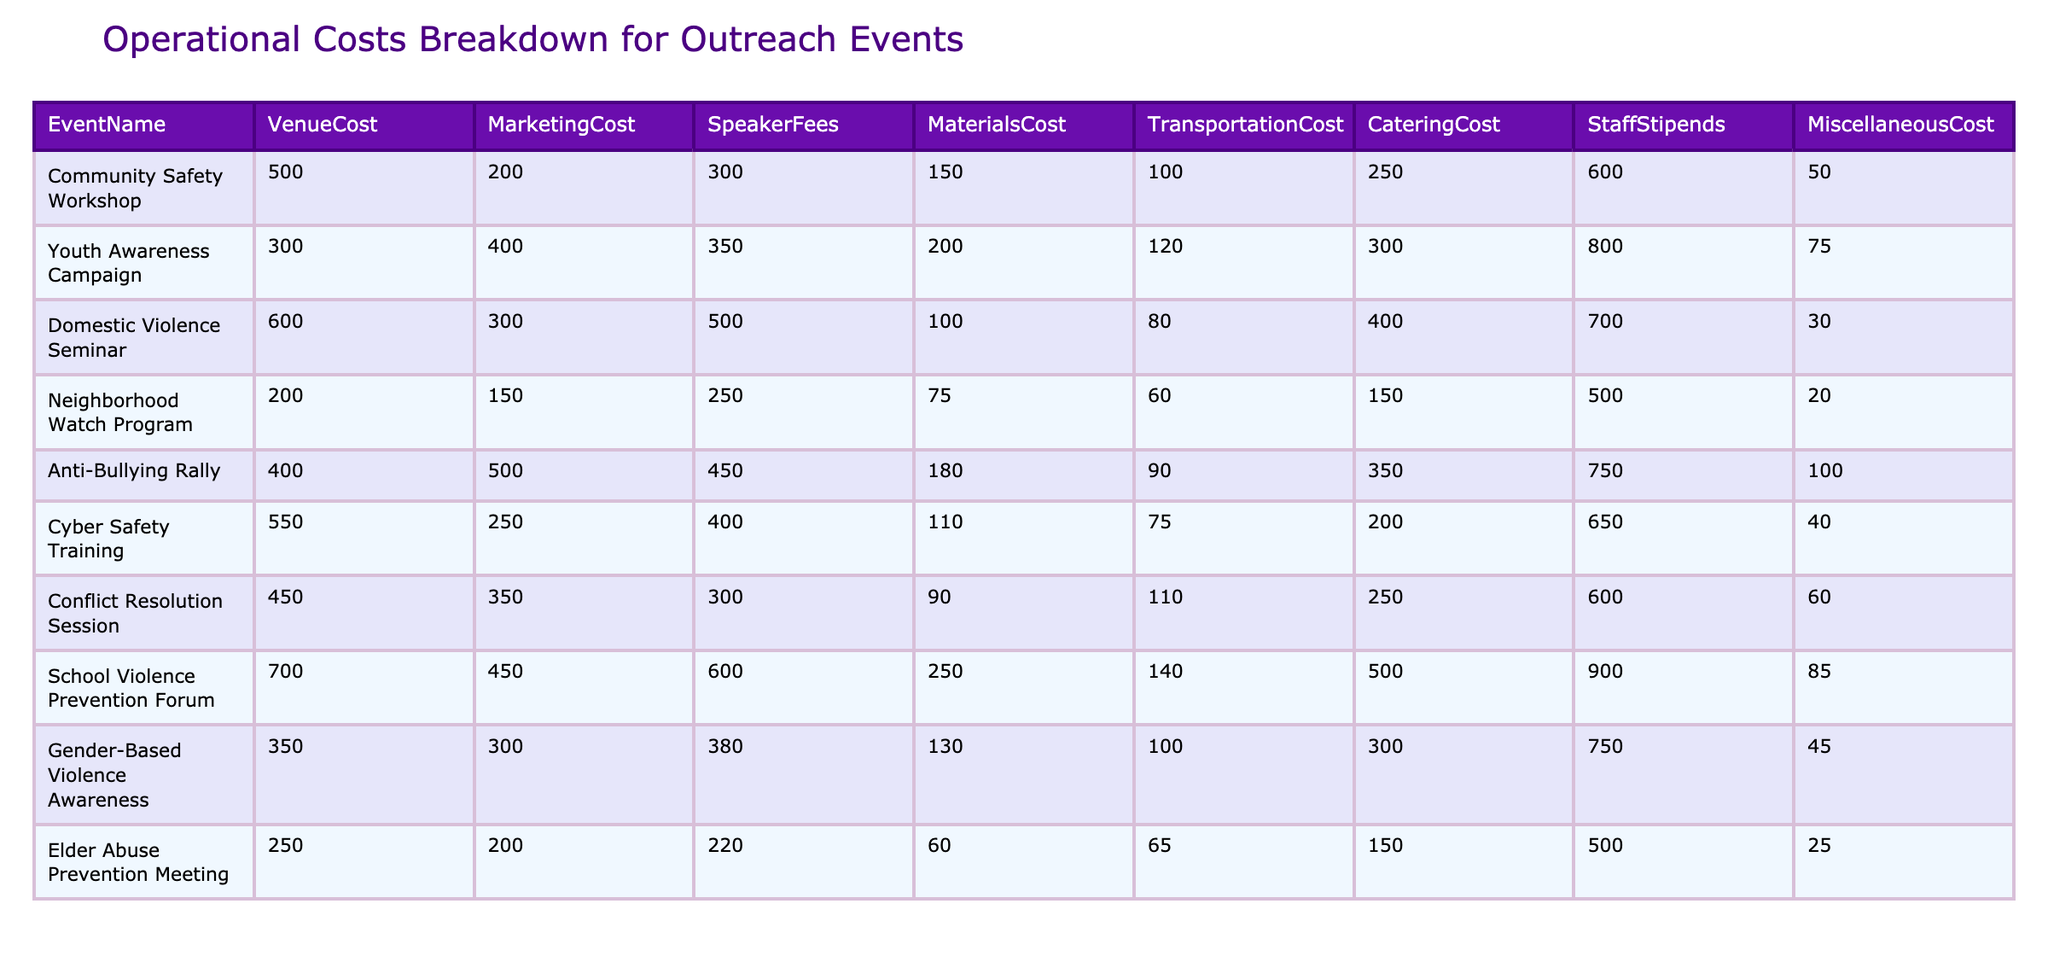What is the total Catering Cost for all events? To find the total Catering Cost, sum the Catering Cost values from each event: 250 + 300 + 400 + 150 + 350 + 200 + 250 + 500 + 300 + 150 = 3150
Answer: 3150 Which event has the highest Speaker Fees? The Speaker Fees are: 300, 350, 500, 250, 450, 400, 300, 600, 380, 220. The highest value here is 600, associated with the School Violence Prevention Forum.
Answer: School Violence Prevention Forum What is the total operational cost for the Anti-Bullying Rally? To calculate the total operational cost for the Anti-Bullying Rally, sum the costs: 400 (Venue) + 500 (Marketing) + 450 (Speaker Fees) + 180 (Materials) + 90 (Transportation) + 350 (Catering) + 750 (Staff Stipends) + 100 (Miscellaneous) = 2020
Answer: 2020 Is the Marketing Cost for the Community Safety Workshop higher than the Marketing Cost for the Elder Abuse Prevention Meeting? The Marketing Cost for the Community Safety Workshop is 200, and for the Elder Abuse Prevention Meeting, it is 200. Since they are equal, the statement is false.
Answer: No What is the average Transportation Cost across all events? Calculate the Transportation Costs: 100, 120, 80, 60, 90, 75, 110, 140, 100, 65. The total is 1010. Divide by the number of events (10): 1010/10 = 101.
Answer: 101 Which event has the lowest Miscellaneous Cost? The Miscellaneous Costs are: 50, 75, 30, 20, 100, 40, 60, 85, 45, 25. The lowest value is 20, related to the Neighborhood Watch Program.
Answer: Neighborhood Watch Program What is the total cost for the Youth Awareness Campaign? To find the total cost, sum the costs for the Youth Awareness Campaign: 300 (Venue) + 400 (Marketing) + 350 (Speaker) + 200 (Materials) + 120 (Transportation) + 300 (Catering) + 800 (Staff Stipends) + 75 (Miscellaneous) = 2575.
Answer: 2575 Is the total Staff Stipends for the Domestic Violence Seminar greater than the total Marketing Cost for the Anti-Bullying Rally? The Staff Stipends for the Domestic Violence Seminar total 700, while the Marketing Cost for the Anti-Bullying Rally is 500. Since 700 is greater than 500, the answer is yes.
Answer: Yes What is the difference between the highest and lowest Venue Costs? The highest Venue Cost is 700 (School Violence Prevention Forum) and the lowest is 200 (Neighborhood Watch Program). The difference is 700 - 200 = 500.
Answer: 500 